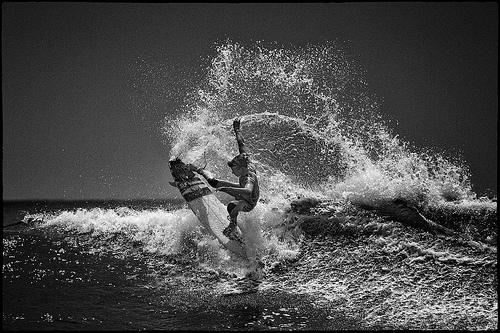If you had to choose one word to describe the mood of this image, what would it be and why? Adventurous, as the image captures a surfer engaging in an extreme sport by riding a wave in the ocean. Describe the environment and weather conditions in the image. The image shows a clear day with dark grey skies above the ocean, where a man is surfing on large waves with white caps and airborne sprays. Identify the primary activity captured in the image. A person is surfing on a surfboard in the ocean, riding a wave. Describe the appearance and design of the surfboard in the image. The surfboard is white with stripes, featuring a black knee pad and a white and black logo that's hard to see. Can you provide a brief summary of the image's content? The image is of a black and white ocean scene, featuring a lone surfer riding a wave with water splashing around. What type of imagery is depicted in the photo? The image shows an ocean scene with a person surfing on a wave, in black and white. What is the overall color scheme of the image and what does this suggest? The image has a black and white color scheme, giving it a vintage or classic feel. What technique is the surfer using to maintain balance on the surfboard? The surfer is stretching their hands and arms in the air to maintain balance while riding the wave. How many people are present in the image, and what is the main action they are performing? Only one person is present in the image, and they are surfing on a wave. 